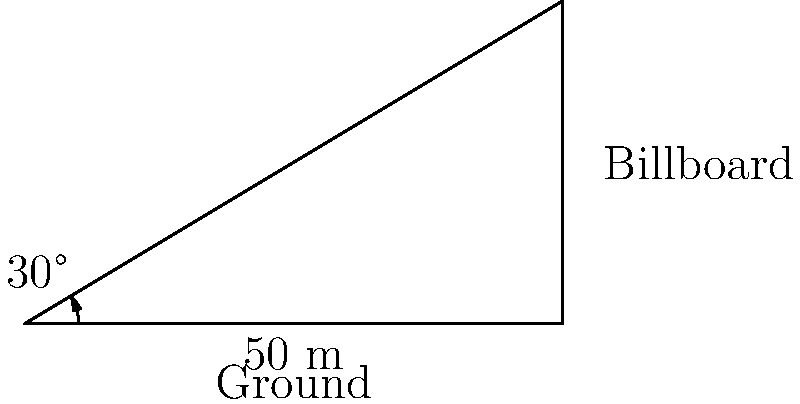You're planning to place a new billboard for a client. Standing 50 meters away from the base of the billboard, you measure the angle of elevation to the top of the billboard to be 30°. How tall is the billboard? Let's approach this step-by-step:

1) We can use the tangent function to solve this problem. The tangent of an angle in a right triangle is the ratio of the opposite side to the adjacent side.

2) In this case:
   - The angle is 30°
   - The adjacent side is the distance from you to the billboard (50 meters)
   - The opposite side is the height of the billboard (what we're trying to find)

3) Let's call the height of the billboard $h$. We can write the equation:

   $\tan(30°) = \frac{h}{50}$

4) We know that $\tan(30°) = \frac{1}{\sqrt{3}}$, so we can rewrite the equation:

   $\frac{1}{\sqrt{3}} = \frac{h}{50}$

5) To solve for $h$, we multiply both sides by 50:

   $\frac{50}{\sqrt{3}} = h$

6) Simplify:
   $h = 50 \cdot \frac{1}{\sqrt{3}} \approx 28.87$ meters

Therefore, the billboard is approximately 28.87 meters tall.
Answer: $28.87$ meters 